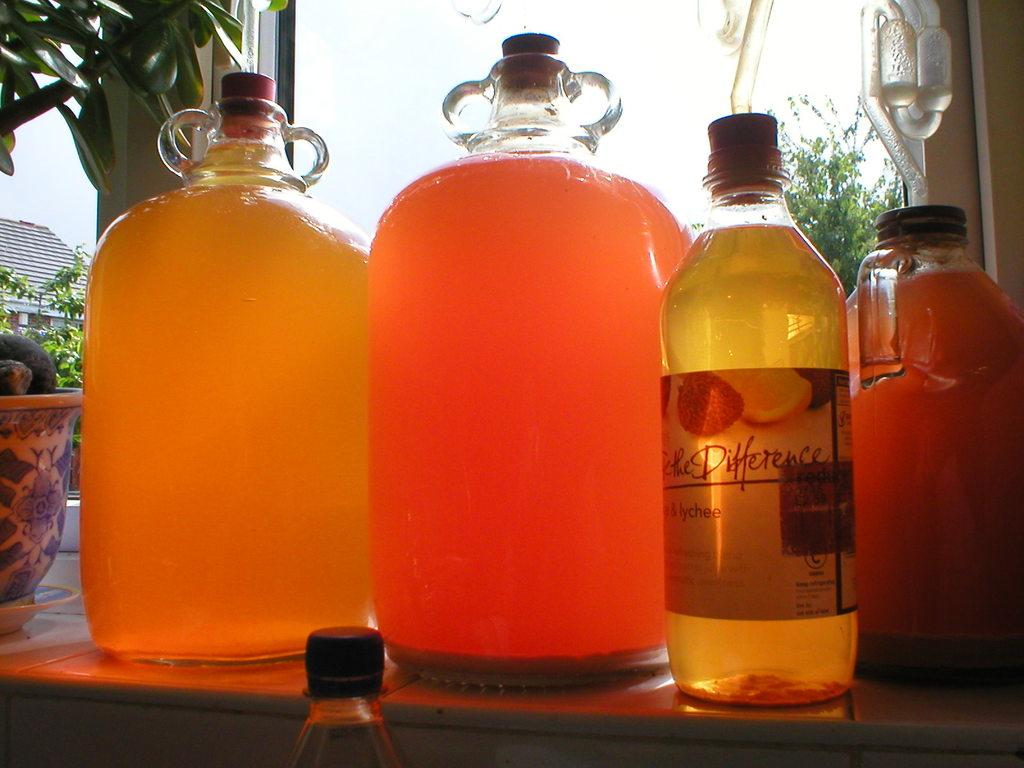<image>
Render a clear and concise summary of the photo. the word difference is on the bottle with liquid 